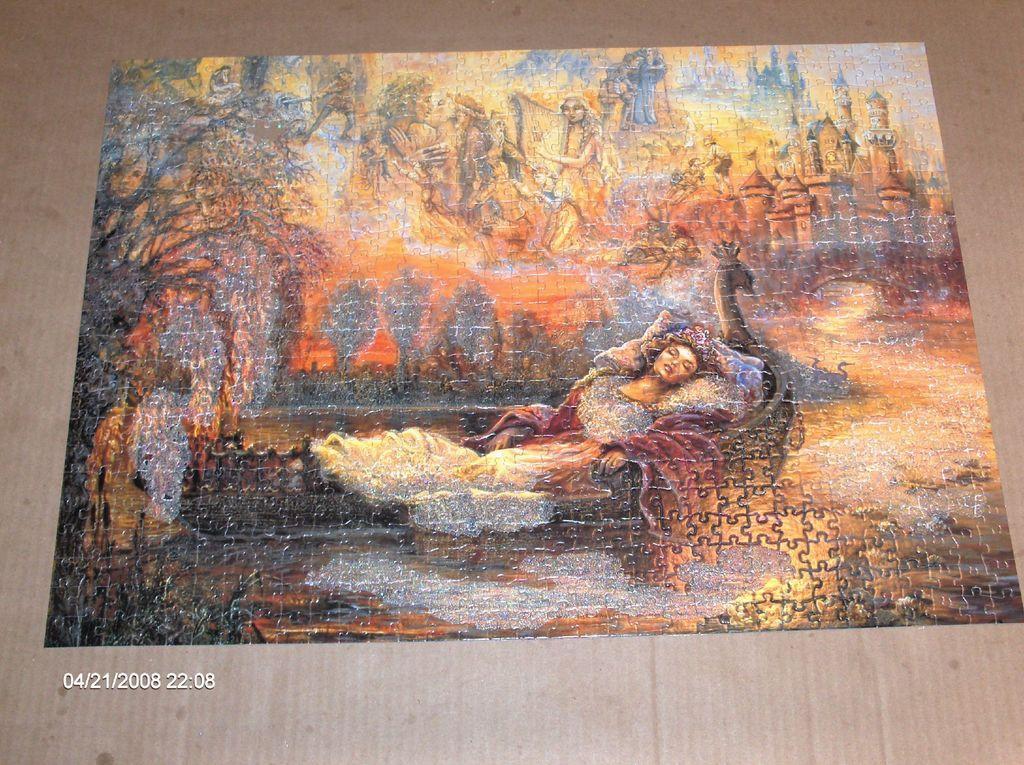Describe this image in one or two sentences. In this picture I can see the jigsaw puzzle and in the puzzle I can see pictures of people and I can see few buildings. I can also see the trees. On the bottom left corner of this picture I can see the watermark and I see that this puzzle is on the brown color surface. 